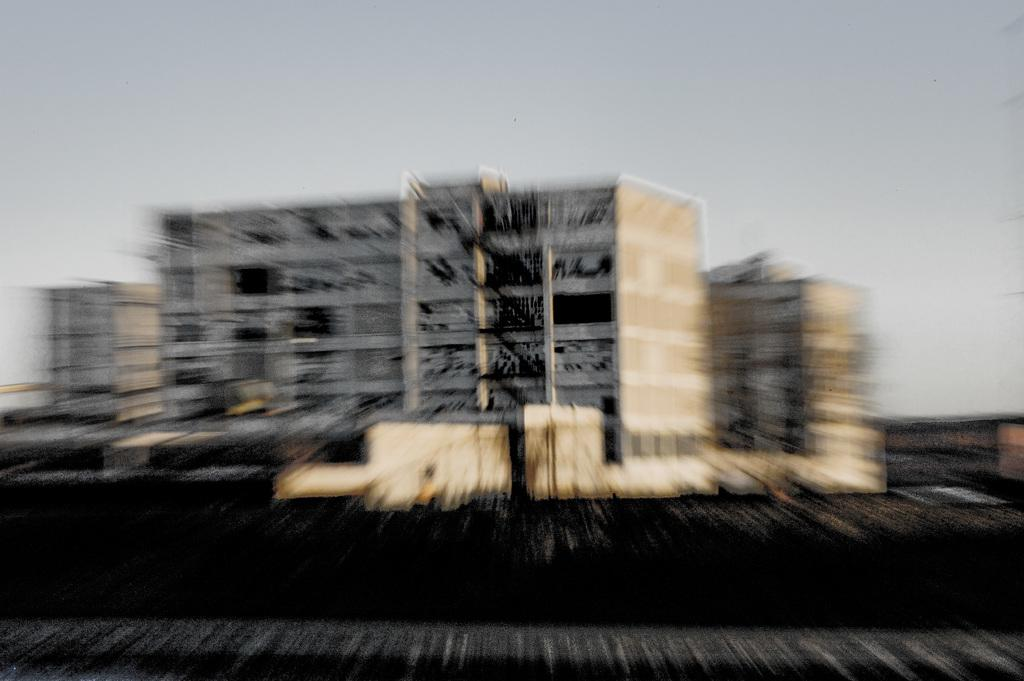What can be observed about the quality of the image? The image is blurry. What structures can be seen in the background of the image? There are buildings in the background of the image. What else is visible in the background of the image? The sky is visible in the background of the image. Are there any fairies visible in the image? There are no fairies present in the image. What type of flame can be seen in the image? There is no flame present in the image. 